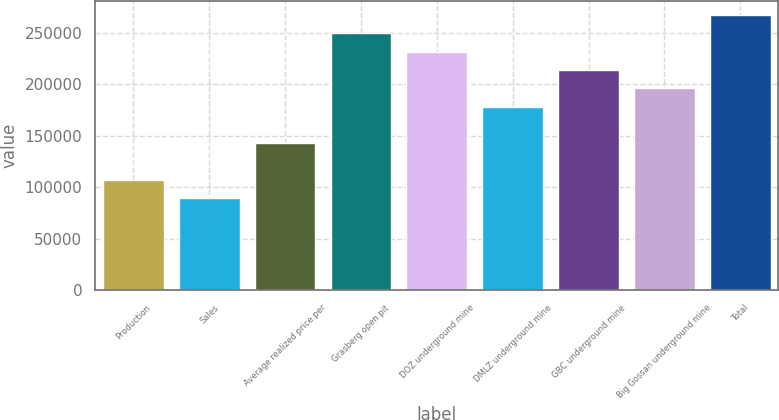Convert chart. <chart><loc_0><loc_0><loc_500><loc_500><bar_chart><fcel>Production<fcel>Sales<fcel>Average realized price per<fcel>Grasberg open pit<fcel>DOZ underground mine<fcel>DMLZ underground mine<fcel>GBC underground mine<fcel>Big Gossan underground mine<fcel>Total<nl><fcel>106860<fcel>89050.5<fcel>142480<fcel>249340<fcel>231530<fcel>178100<fcel>213720<fcel>195910<fcel>267149<nl></chart> 